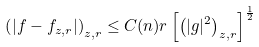Convert formula to latex. <formula><loc_0><loc_0><loc_500><loc_500>\left ( | f - f _ { z , r } | \right ) _ { z , r } \leq C ( n ) r \left [ \left ( | g | ^ { 2 } \right ) _ { z , r } \right ] ^ { \frac { 1 } { 2 } }</formula> 